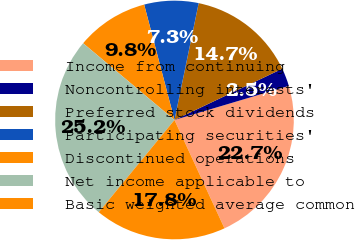Convert chart. <chart><loc_0><loc_0><loc_500><loc_500><pie_chart><fcel>Income from continuing<fcel>Noncontrolling interests'<fcel>Preferred stock dividends<fcel>Participating securities'<fcel>Discontinued operations<fcel>Net income applicable to<fcel>Basic weighted average common<nl><fcel>22.73%<fcel>2.45%<fcel>14.69%<fcel>7.34%<fcel>9.79%<fcel>25.18%<fcel>17.82%<nl></chart> 